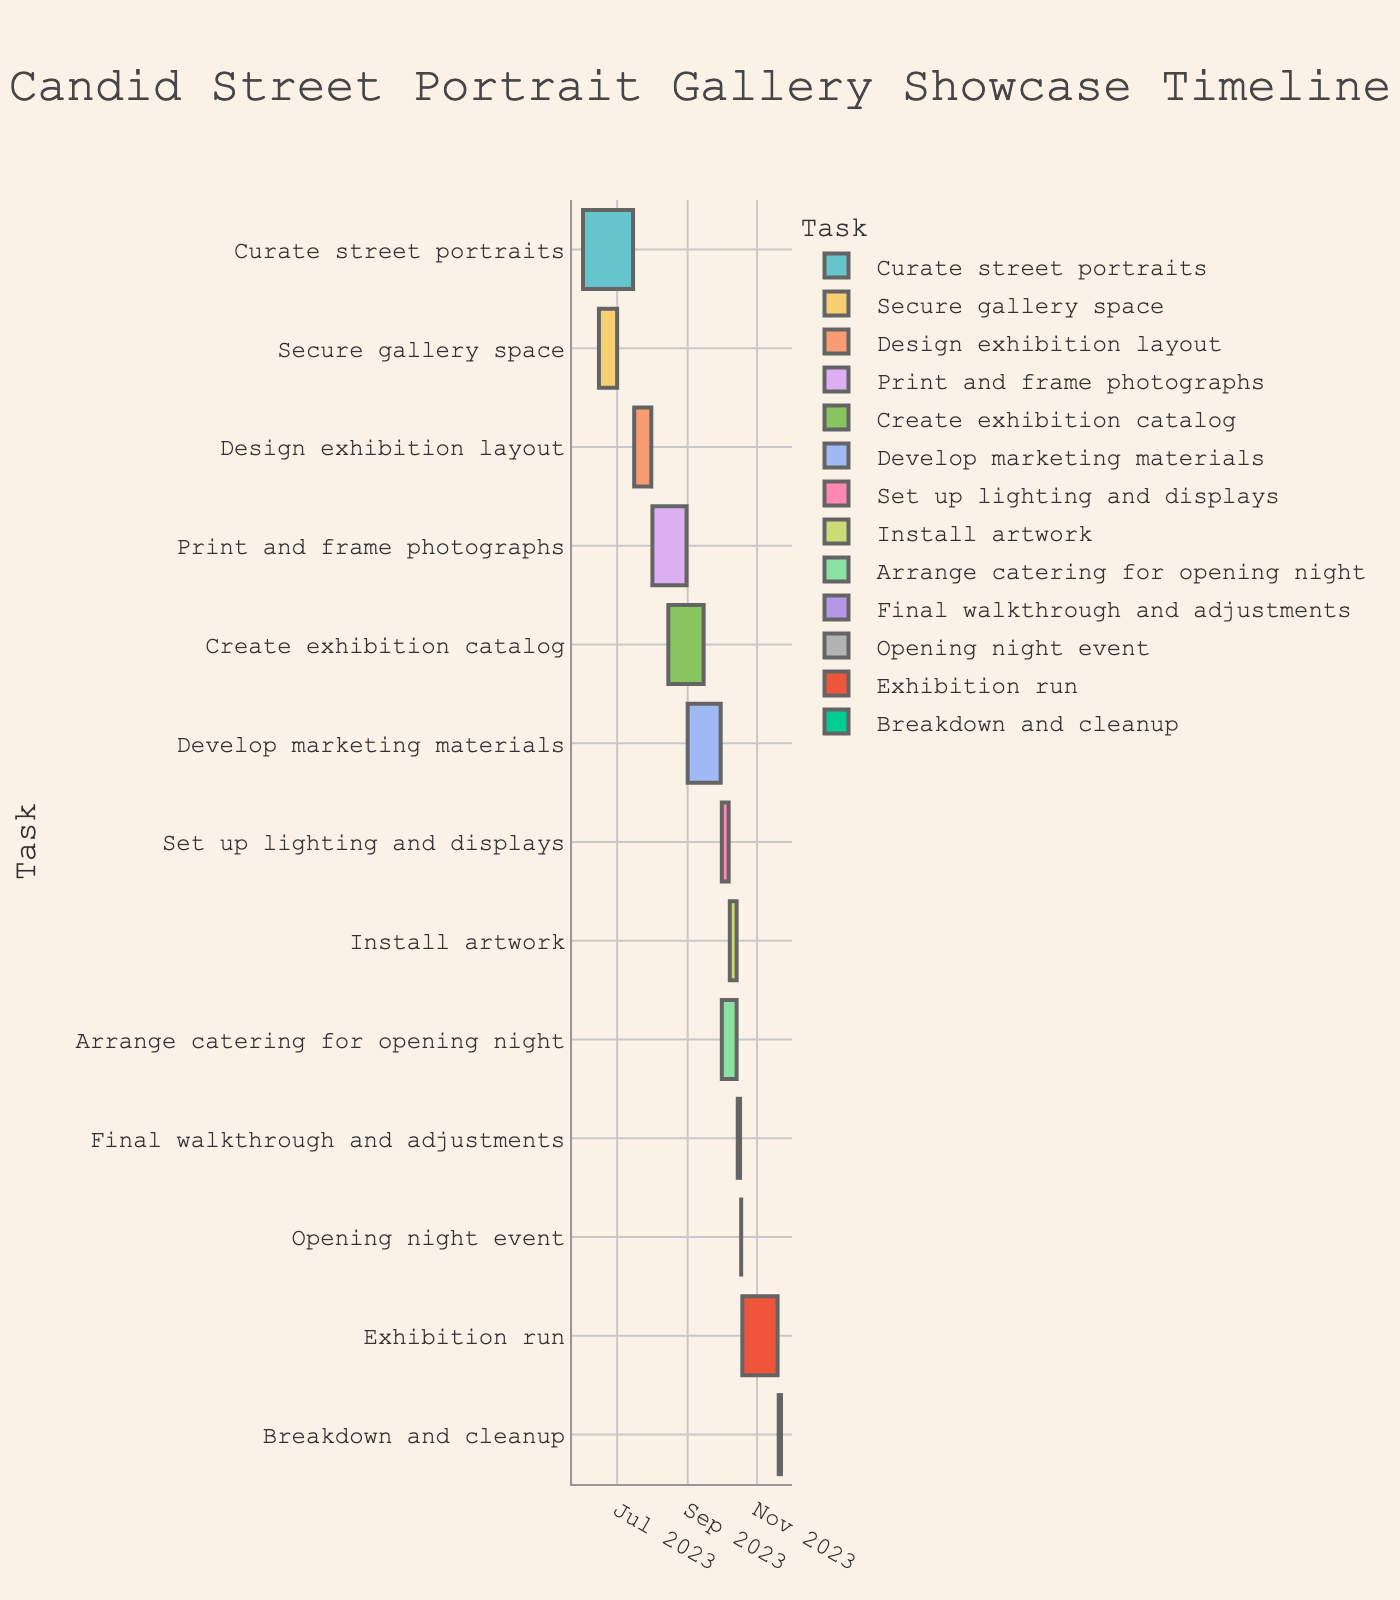What is the title of the Gantt chart? The title is displayed at the top of the chart, providing an overview of what the chart represents. By looking at the top, we see the title.
Answer: Candid Street Portrait Gallery Showcase Timeline Which task has the longest duration? To find this, look at the length of the bars representing tasks. The longest bar indicates the task with the longest duration.
Answer: Exhibition run How long does the "Print and frame photographs" task take? Identify the bar for "Print and frame photographs," then look at the start and end dates to calculate the duration. Subtract the start date (August 1, 2023) from the end date (August 31, 2023).
Answer: 31 days Which two tasks overlap in August? Identify tasks that span the month of August. Then check which ones have bars that overlap in this period.
Answer: Print and frame photographs, Create exhibition catalog What is the total duration from the start of "Curate street portraits" to the end of "Breakdown and cleanup"? Find the start date of "Curate street portraits" (June 1, 2023) and the end date of "Breakdown and cleanup" (November 22, 2023). Calculate the total days between these dates.
Answer: 175 days Is the "Opening night event" before or after the "Exhibition run"? Identify the start date of "Opening night event" (October 18, 2023) and compare it to the start date of "Exhibition run" (October 19, 2023).
Answer: Before What's the average duration of tasks starting in October? List all tasks starting in October and find their durations. Sum the durations and divide by the number of tasks. Tasks: Set up lighting and displays (7 days), Install artwork (7 days), Arrange catering for opening night (14 days), Final walkthrough and adjustments (3 days), Opening night event (1 day). Average = (7 + 7 + 14 + 3 + 1)/5.
Answer: 6.4 days How many tasks are scheduled to start in September? Count the number of tasks that have their start dates in September. This involves locating tasks with a start date from September 1 to September 30, 2023.
Answer: 1 task Which task ends last in the timeline? Identify the task that finishes the latest by looking at the end dates and selecting the latest one.
Answer: Breakdown and cleanup Do any tasks start in July but end in August? Check for tasks with start dates in July and end dates in August. Look for bars that span from July into August in the timeline.
Answer: None 